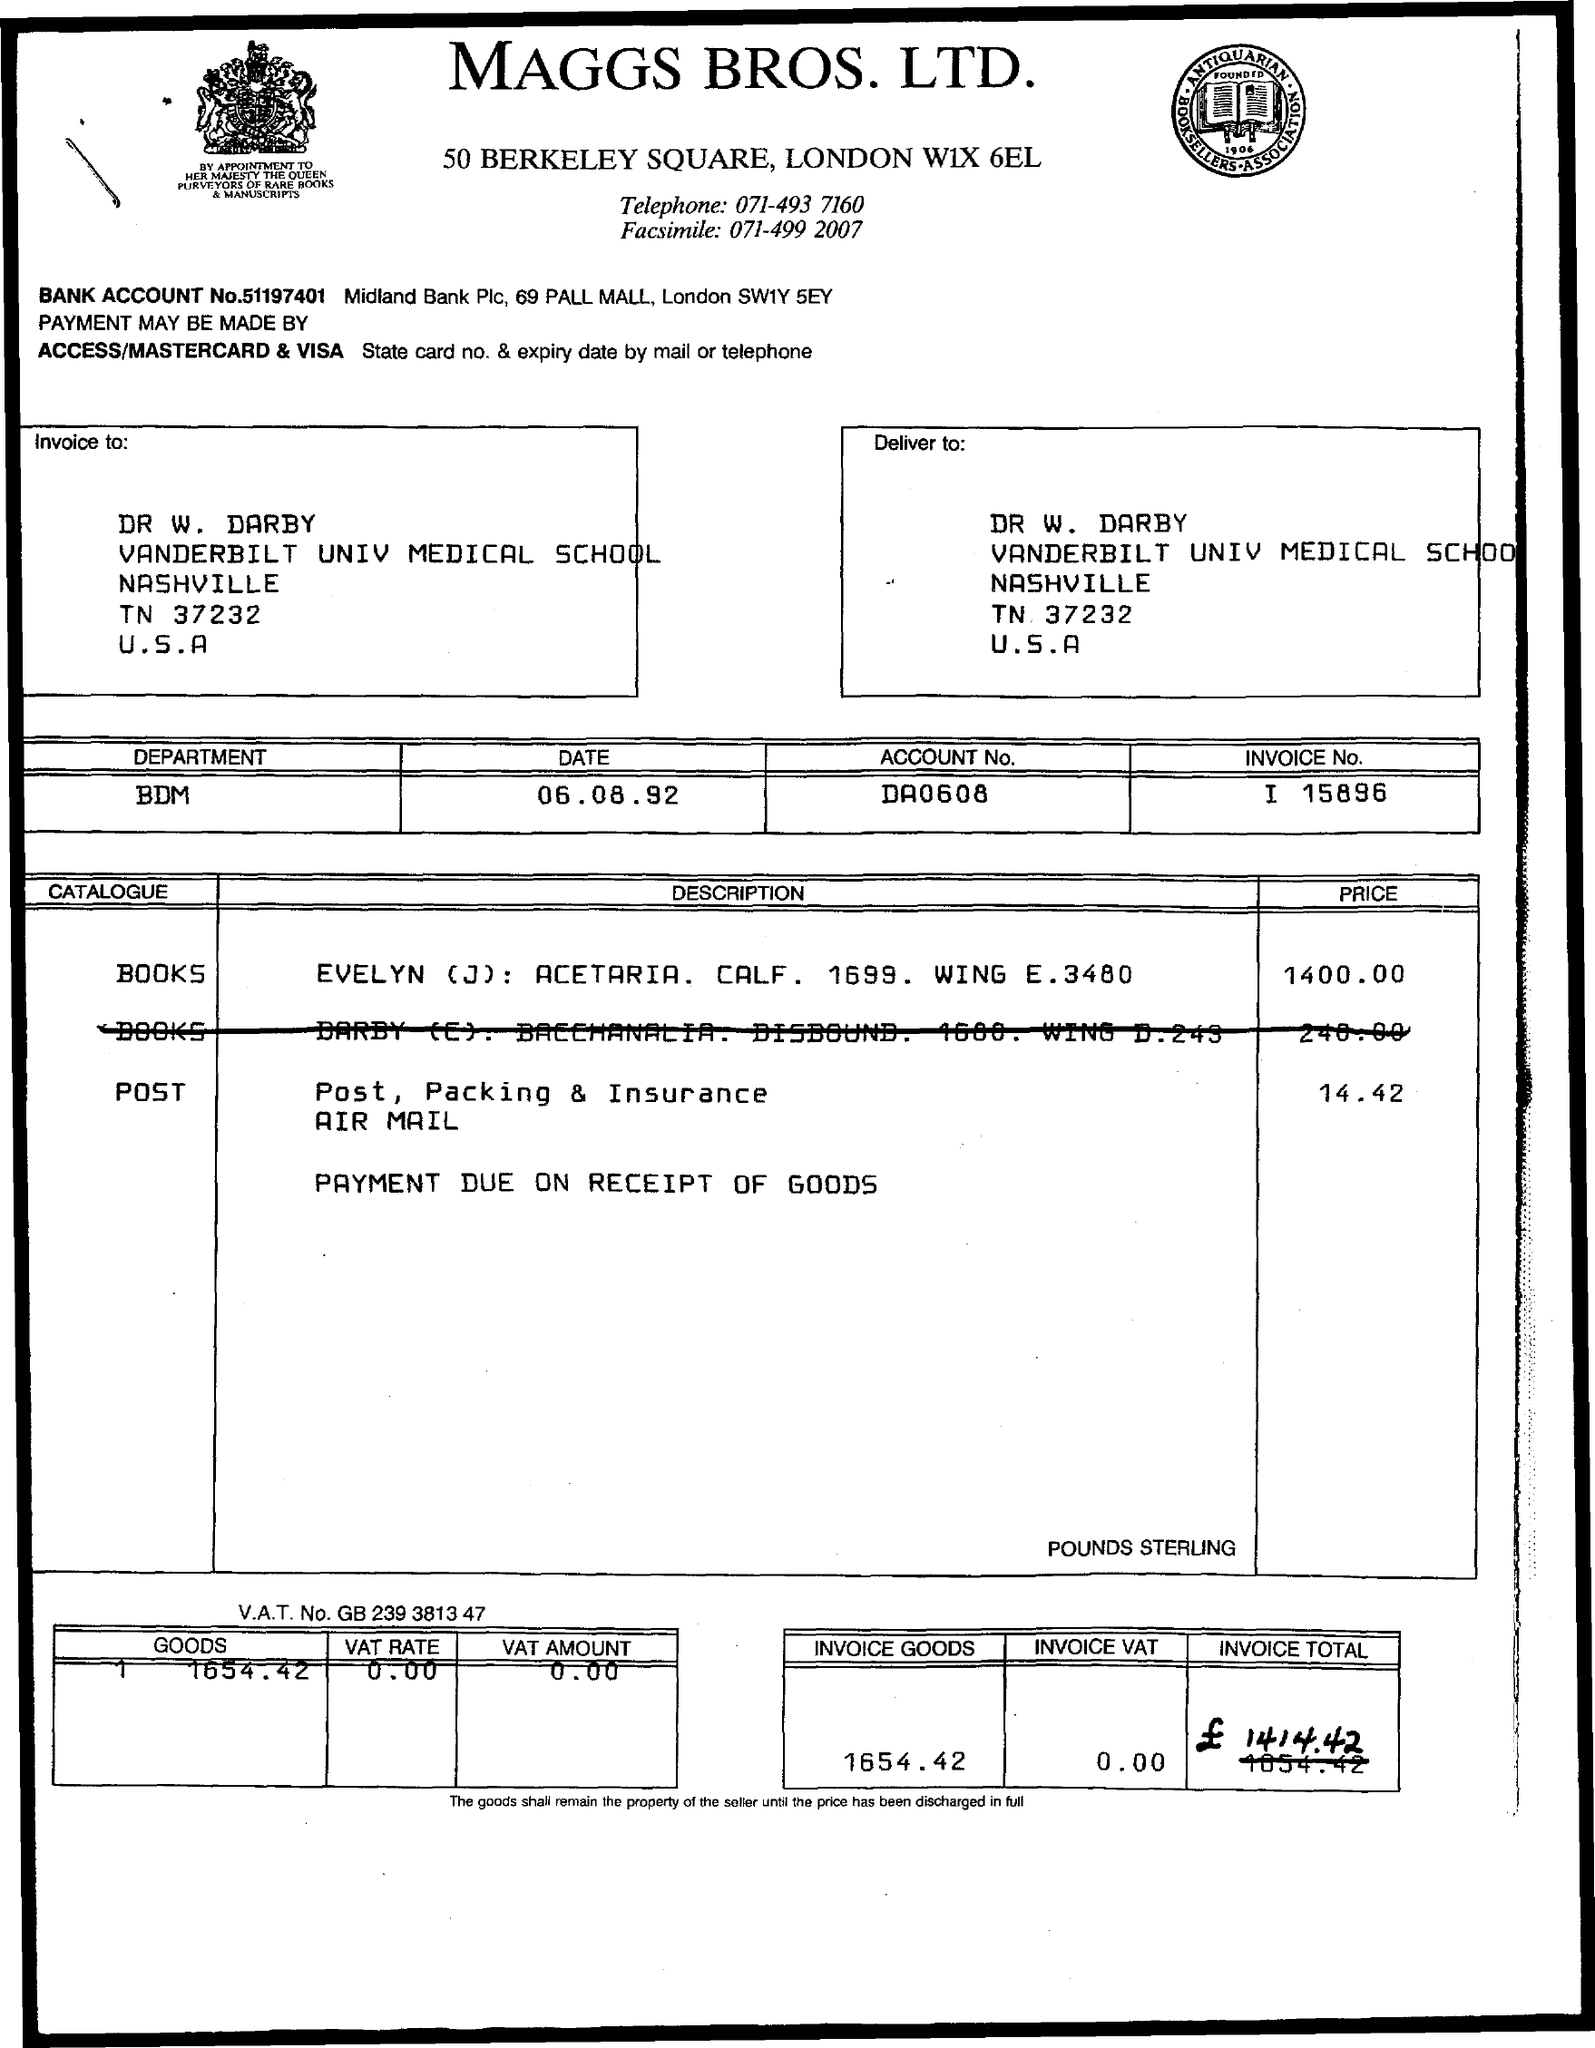What items are being charged for on this invoice? The invoice charges are for two books: 'Evelyn (J): Acetaria. Calf. 1699. Wing E.3480' priced at £1400.00 and 'Darby (T+): Praelectiones. Disbound. 1660. Wing D.243' priced at £240.00. 